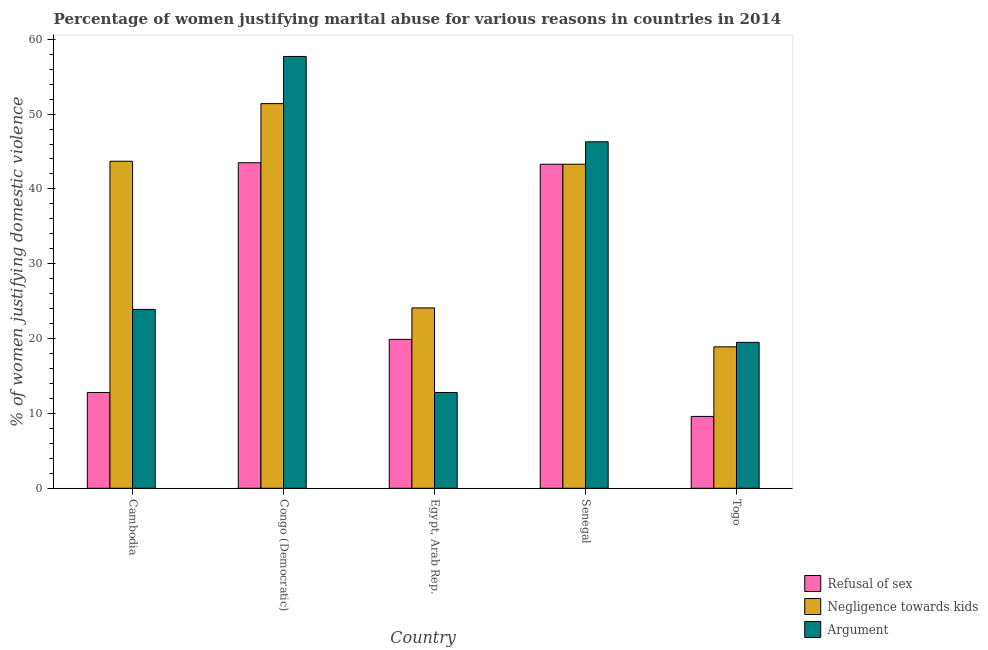How many different coloured bars are there?
Your answer should be compact. 3. Are the number of bars per tick equal to the number of legend labels?
Keep it short and to the point. Yes. Are the number of bars on each tick of the X-axis equal?
Your answer should be very brief. Yes. How many bars are there on the 4th tick from the left?
Your answer should be compact. 3. How many bars are there on the 1st tick from the right?
Your answer should be very brief. 3. What is the label of the 3rd group of bars from the left?
Provide a succinct answer. Egypt, Arab Rep. Across all countries, what is the maximum percentage of women justifying domestic violence due to arguments?
Your response must be concise. 57.7. In which country was the percentage of women justifying domestic violence due to negligence towards kids maximum?
Offer a terse response. Congo (Democratic). In which country was the percentage of women justifying domestic violence due to arguments minimum?
Make the answer very short. Egypt, Arab Rep. What is the total percentage of women justifying domestic violence due to arguments in the graph?
Offer a very short reply. 160.2. What is the difference between the percentage of women justifying domestic violence due to arguments in Cambodia and that in Egypt, Arab Rep.?
Keep it short and to the point. 11.1. What is the difference between the percentage of women justifying domestic violence due to arguments in Togo and the percentage of women justifying domestic violence due to refusal of sex in Egypt, Arab Rep.?
Provide a succinct answer. -0.4. What is the average percentage of women justifying domestic violence due to negligence towards kids per country?
Your response must be concise. 36.28. What is the difference between the percentage of women justifying domestic violence due to refusal of sex and percentage of women justifying domestic violence due to negligence towards kids in Congo (Democratic)?
Your answer should be compact. -7.9. In how many countries, is the percentage of women justifying domestic violence due to refusal of sex greater than 20 %?
Offer a very short reply. 2. What is the ratio of the percentage of women justifying domestic violence due to negligence towards kids in Congo (Democratic) to that in Togo?
Provide a short and direct response. 2.72. Is the percentage of women justifying domestic violence due to arguments in Egypt, Arab Rep. less than that in Senegal?
Offer a very short reply. Yes. What is the difference between the highest and the second highest percentage of women justifying domestic violence due to negligence towards kids?
Offer a terse response. 7.7. What is the difference between the highest and the lowest percentage of women justifying domestic violence due to negligence towards kids?
Offer a terse response. 32.5. Is the sum of the percentage of women justifying domestic violence due to negligence towards kids in Cambodia and Congo (Democratic) greater than the maximum percentage of women justifying domestic violence due to refusal of sex across all countries?
Give a very brief answer. Yes. What does the 3rd bar from the left in Senegal represents?
Make the answer very short. Argument. What does the 2nd bar from the right in Senegal represents?
Your answer should be compact. Negligence towards kids. Is it the case that in every country, the sum of the percentage of women justifying domestic violence due to refusal of sex and percentage of women justifying domestic violence due to negligence towards kids is greater than the percentage of women justifying domestic violence due to arguments?
Ensure brevity in your answer.  Yes. What is the difference between two consecutive major ticks on the Y-axis?
Offer a terse response. 10. Are the values on the major ticks of Y-axis written in scientific E-notation?
Your response must be concise. No. Where does the legend appear in the graph?
Your answer should be very brief. Bottom right. How many legend labels are there?
Offer a terse response. 3. How are the legend labels stacked?
Keep it short and to the point. Vertical. What is the title of the graph?
Your answer should be compact. Percentage of women justifying marital abuse for various reasons in countries in 2014. Does "Taxes on income" appear as one of the legend labels in the graph?
Your answer should be compact. No. What is the label or title of the Y-axis?
Give a very brief answer. % of women justifying domestic violence. What is the % of women justifying domestic violence in Refusal of sex in Cambodia?
Your answer should be very brief. 12.8. What is the % of women justifying domestic violence of Negligence towards kids in Cambodia?
Your answer should be very brief. 43.7. What is the % of women justifying domestic violence of Argument in Cambodia?
Offer a very short reply. 23.9. What is the % of women justifying domestic violence of Refusal of sex in Congo (Democratic)?
Provide a succinct answer. 43.5. What is the % of women justifying domestic violence of Negligence towards kids in Congo (Democratic)?
Your answer should be very brief. 51.4. What is the % of women justifying domestic violence in Argument in Congo (Democratic)?
Your answer should be compact. 57.7. What is the % of women justifying domestic violence of Refusal of sex in Egypt, Arab Rep.?
Your answer should be compact. 19.9. What is the % of women justifying domestic violence of Negligence towards kids in Egypt, Arab Rep.?
Keep it short and to the point. 24.1. What is the % of women justifying domestic violence of Refusal of sex in Senegal?
Give a very brief answer. 43.3. What is the % of women justifying domestic violence in Negligence towards kids in Senegal?
Ensure brevity in your answer.  43.3. What is the % of women justifying domestic violence in Argument in Senegal?
Keep it short and to the point. 46.3. What is the % of women justifying domestic violence in Refusal of sex in Togo?
Offer a terse response. 9.6. What is the % of women justifying domestic violence in Negligence towards kids in Togo?
Your response must be concise. 18.9. Across all countries, what is the maximum % of women justifying domestic violence in Refusal of sex?
Offer a terse response. 43.5. Across all countries, what is the maximum % of women justifying domestic violence of Negligence towards kids?
Give a very brief answer. 51.4. Across all countries, what is the maximum % of women justifying domestic violence of Argument?
Ensure brevity in your answer.  57.7. Across all countries, what is the minimum % of women justifying domestic violence in Refusal of sex?
Your answer should be very brief. 9.6. Across all countries, what is the minimum % of women justifying domestic violence in Negligence towards kids?
Provide a succinct answer. 18.9. Across all countries, what is the minimum % of women justifying domestic violence in Argument?
Give a very brief answer. 12.8. What is the total % of women justifying domestic violence in Refusal of sex in the graph?
Your answer should be very brief. 129.1. What is the total % of women justifying domestic violence of Negligence towards kids in the graph?
Offer a very short reply. 181.4. What is the total % of women justifying domestic violence of Argument in the graph?
Keep it short and to the point. 160.2. What is the difference between the % of women justifying domestic violence in Refusal of sex in Cambodia and that in Congo (Democratic)?
Ensure brevity in your answer.  -30.7. What is the difference between the % of women justifying domestic violence in Negligence towards kids in Cambodia and that in Congo (Democratic)?
Make the answer very short. -7.7. What is the difference between the % of women justifying domestic violence of Argument in Cambodia and that in Congo (Democratic)?
Offer a very short reply. -33.8. What is the difference between the % of women justifying domestic violence of Negligence towards kids in Cambodia and that in Egypt, Arab Rep.?
Offer a very short reply. 19.6. What is the difference between the % of women justifying domestic violence in Argument in Cambodia and that in Egypt, Arab Rep.?
Your answer should be very brief. 11.1. What is the difference between the % of women justifying domestic violence in Refusal of sex in Cambodia and that in Senegal?
Provide a succinct answer. -30.5. What is the difference between the % of women justifying domestic violence in Argument in Cambodia and that in Senegal?
Offer a very short reply. -22.4. What is the difference between the % of women justifying domestic violence of Negligence towards kids in Cambodia and that in Togo?
Offer a very short reply. 24.8. What is the difference between the % of women justifying domestic violence in Argument in Cambodia and that in Togo?
Make the answer very short. 4.4. What is the difference between the % of women justifying domestic violence in Refusal of sex in Congo (Democratic) and that in Egypt, Arab Rep.?
Your answer should be very brief. 23.6. What is the difference between the % of women justifying domestic violence of Negligence towards kids in Congo (Democratic) and that in Egypt, Arab Rep.?
Provide a succinct answer. 27.3. What is the difference between the % of women justifying domestic violence of Argument in Congo (Democratic) and that in Egypt, Arab Rep.?
Provide a short and direct response. 44.9. What is the difference between the % of women justifying domestic violence of Negligence towards kids in Congo (Democratic) and that in Senegal?
Give a very brief answer. 8.1. What is the difference between the % of women justifying domestic violence of Refusal of sex in Congo (Democratic) and that in Togo?
Your response must be concise. 33.9. What is the difference between the % of women justifying domestic violence in Negligence towards kids in Congo (Democratic) and that in Togo?
Make the answer very short. 32.5. What is the difference between the % of women justifying domestic violence in Argument in Congo (Democratic) and that in Togo?
Keep it short and to the point. 38.2. What is the difference between the % of women justifying domestic violence in Refusal of sex in Egypt, Arab Rep. and that in Senegal?
Your answer should be very brief. -23.4. What is the difference between the % of women justifying domestic violence of Negligence towards kids in Egypt, Arab Rep. and that in Senegal?
Make the answer very short. -19.2. What is the difference between the % of women justifying domestic violence of Argument in Egypt, Arab Rep. and that in Senegal?
Offer a terse response. -33.5. What is the difference between the % of women justifying domestic violence in Argument in Egypt, Arab Rep. and that in Togo?
Your answer should be compact. -6.7. What is the difference between the % of women justifying domestic violence of Refusal of sex in Senegal and that in Togo?
Ensure brevity in your answer.  33.7. What is the difference between the % of women justifying domestic violence in Negligence towards kids in Senegal and that in Togo?
Your answer should be compact. 24.4. What is the difference between the % of women justifying domestic violence in Argument in Senegal and that in Togo?
Offer a very short reply. 26.8. What is the difference between the % of women justifying domestic violence of Refusal of sex in Cambodia and the % of women justifying domestic violence of Negligence towards kids in Congo (Democratic)?
Keep it short and to the point. -38.6. What is the difference between the % of women justifying domestic violence in Refusal of sex in Cambodia and the % of women justifying domestic violence in Argument in Congo (Democratic)?
Ensure brevity in your answer.  -44.9. What is the difference between the % of women justifying domestic violence of Refusal of sex in Cambodia and the % of women justifying domestic violence of Negligence towards kids in Egypt, Arab Rep.?
Your answer should be very brief. -11.3. What is the difference between the % of women justifying domestic violence in Negligence towards kids in Cambodia and the % of women justifying domestic violence in Argument in Egypt, Arab Rep.?
Make the answer very short. 30.9. What is the difference between the % of women justifying domestic violence of Refusal of sex in Cambodia and the % of women justifying domestic violence of Negligence towards kids in Senegal?
Offer a terse response. -30.5. What is the difference between the % of women justifying domestic violence in Refusal of sex in Cambodia and the % of women justifying domestic violence in Argument in Senegal?
Give a very brief answer. -33.5. What is the difference between the % of women justifying domestic violence in Negligence towards kids in Cambodia and the % of women justifying domestic violence in Argument in Togo?
Give a very brief answer. 24.2. What is the difference between the % of women justifying domestic violence in Refusal of sex in Congo (Democratic) and the % of women justifying domestic violence in Argument in Egypt, Arab Rep.?
Provide a succinct answer. 30.7. What is the difference between the % of women justifying domestic violence in Negligence towards kids in Congo (Democratic) and the % of women justifying domestic violence in Argument in Egypt, Arab Rep.?
Make the answer very short. 38.6. What is the difference between the % of women justifying domestic violence of Refusal of sex in Congo (Democratic) and the % of women justifying domestic violence of Negligence towards kids in Senegal?
Offer a very short reply. 0.2. What is the difference between the % of women justifying domestic violence in Refusal of sex in Congo (Democratic) and the % of women justifying domestic violence in Argument in Senegal?
Your response must be concise. -2.8. What is the difference between the % of women justifying domestic violence of Refusal of sex in Congo (Democratic) and the % of women justifying domestic violence of Negligence towards kids in Togo?
Keep it short and to the point. 24.6. What is the difference between the % of women justifying domestic violence of Refusal of sex in Congo (Democratic) and the % of women justifying domestic violence of Argument in Togo?
Give a very brief answer. 24. What is the difference between the % of women justifying domestic violence in Negligence towards kids in Congo (Democratic) and the % of women justifying domestic violence in Argument in Togo?
Offer a terse response. 31.9. What is the difference between the % of women justifying domestic violence of Refusal of sex in Egypt, Arab Rep. and the % of women justifying domestic violence of Negligence towards kids in Senegal?
Keep it short and to the point. -23.4. What is the difference between the % of women justifying domestic violence of Refusal of sex in Egypt, Arab Rep. and the % of women justifying domestic violence of Argument in Senegal?
Make the answer very short. -26.4. What is the difference between the % of women justifying domestic violence in Negligence towards kids in Egypt, Arab Rep. and the % of women justifying domestic violence in Argument in Senegal?
Offer a very short reply. -22.2. What is the difference between the % of women justifying domestic violence in Refusal of sex in Egypt, Arab Rep. and the % of women justifying domestic violence in Negligence towards kids in Togo?
Your response must be concise. 1. What is the difference between the % of women justifying domestic violence of Negligence towards kids in Egypt, Arab Rep. and the % of women justifying domestic violence of Argument in Togo?
Ensure brevity in your answer.  4.6. What is the difference between the % of women justifying domestic violence in Refusal of sex in Senegal and the % of women justifying domestic violence in Negligence towards kids in Togo?
Offer a terse response. 24.4. What is the difference between the % of women justifying domestic violence in Refusal of sex in Senegal and the % of women justifying domestic violence in Argument in Togo?
Make the answer very short. 23.8. What is the difference between the % of women justifying domestic violence in Negligence towards kids in Senegal and the % of women justifying domestic violence in Argument in Togo?
Offer a very short reply. 23.8. What is the average % of women justifying domestic violence in Refusal of sex per country?
Make the answer very short. 25.82. What is the average % of women justifying domestic violence of Negligence towards kids per country?
Offer a very short reply. 36.28. What is the average % of women justifying domestic violence in Argument per country?
Keep it short and to the point. 32.04. What is the difference between the % of women justifying domestic violence of Refusal of sex and % of women justifying domestic violence of Negligence towards kids in Cambodia?
Your response must be concise. -30.9. What is the difference between the % of women justifying domestic violence in Negligence towards kids and % of women justifying domestic violence in Argument in Cambodia?
Your answer should be very brief. 19.8. What is the difference between the % of women justifying domestic violence in Refusal of sex and % of women justifying domestic violence in Negligence towards kids in Congo (Democratic)?
Provide a succinct answer. -7.9. What is the difference between the % of women justifying domestic violence of Refusal of sex and % of women justifying domestic violence of Argument in Congo (Democratic)?
Give a very brief answer. -14.2. What is the difference between the % of women justifying domestic violence in Refusal of sex and % of women justifying domestic violence in Negligence towards kids in Egypt, Arab Rep.?
Your answer should be compact. -4.2. What is the difference between the % of women justifying domestic violence of Negligence towards kids and % of women justifying domestic violence of Argument in Egypt, Arab Rep.?
Make the answer very short. 11.3. What is the difference between the % of women justifying domestic violence in Refusal of sex and % of women justifying domestic violence in Negligence towards kids in Senegal?
Your answer should be compact. 0. What is the ratio of the % of women justifying domestic violence in Refusal of sex in Cambodia to that in Congo (Democratic)?
Your response must be concise. 0.29. What is the ratio of the % of women justifying domestic violence in Negligence towards kids in Cambodia to that in Congo (Democratic)?
Offer a terse response. 0.85. What is the ratio of the % of women justifying domestic violence of Argument in Cambodia to that in Congo (Democratic)?
Provide a short and direct response. 0.41. What is the ratio of the % of women justifying domestic violence in Refusal of sex in Cambodia to that in Egypt, Arab Rep.?
Your response must be concise. 0.64. What is the ratio of the % of women justifying domestic violence of Negligence towards kids in Cambodia to that in Egypt, Arab Rep.?
Make the answer very short. 1.81. What is the ratio of the % of women justifying domestic violence in Argument in Cambodia to that in Egypt, Arab Rep.?
Provide a short and direct response. 1.87. What is the ratio of the % of women justifying domestic violence in Refusal of sex in Cambodia to that in Senegal?
Your answer should be very brief. 0.3. What is the ratio of the % of women justifying domestic violence of Negligence towards kids in Cambodia to that in Senegal?
Make the answer very short. 1.01. What is the ratio of the % of women justifying domestic violence of Argument in Cambodia to that in Senegal?
Your answer should be compact. 0.52. What is the ratio of the % of women justifying domestic violence of Refusal of sex in Cambodia to that in Togo?
Your answer should be compact. 1.33. What is the ratio of the % of women justifying domestic violence in Negligence towards kids in Cambodia to that in Togo?
Give a very brief answer. 2.31. What is the ratio of the % of women justifying domestic violence of Argument in Cambodia to that in Togo?
Your response must be concise. 1.23. What is the ratio of the % of women justifying domestic violence of Refusal of sex in Congo (Democratic) to that in Egypt, Arab Rep.?
Keep it short and to the point. 2.19. What is the ratio of the % of women justifying domestic violence of Negligence towards kids in Congo (Democratic) to that in Egypt, Arab Rep.?
Your answer should be compact. 2.13. What is the ratio of the % of women justifying domestic violence of Argument in Congo (Democratic) to that in Egypt, Arab Rep.?
Offer a very short reply. 4.51. What is the ratio of the % of women justifying domestic violence of Negligence towards kids in Congo (Democratic) to that in Senegal?
Your answer should be compact. 1.19. What is the ratio of the % of women justifying domestic violence in Argument in Congo (Democratic) to that in Senegal?
Keep it short and to the point. 1.25. What is the ratio of the % of women justifying domestic violence in Refusal of sex in Congo (Democratic) to that in Togo?
Your answer should be very brief. 4.53. What is the ratio of the % of women justifying domestic violence of Negligence towards kids in Congo (Democratic) to that in Togo?
Offer a terse response. 2.72. What is the ratio of the % of women justifying domestic violence in Argument in Congo (Democratic) to that in Togo?
Provide a short and direct response. 2.96. What is the ratio of the % of women justifying domestic violence in Refusal of sex in Egypt, Arab Rep. to that in Senegal?
Keep it short and to the point. 0.46. What is the ratio of the % of women justifying domestic violence in Negligence towards kids in Egypt, Arab Rep. to that in Senegal?
Offer a very short reply. 0.56. What is the ratio of the % of women justifying domestic violence in Argument in Egypt, Arab Rep. to that in Senegal?
Your answer should be very brief. 0.28. What is the ratio of the % of women justifying domestic violence in Refusal of sex in Egypt, Arab Rep. to that in Togo?
Provide a short and direct response. 2.07. What is the ratio of the % of women justifying domestic violence of Negligence towards kids in Egypt, Arab Rep. to that in Togo?
Ensure brevity in your answer.  1.28. What is the ratio of the % of women justifying domestic violence of Argument in Egypt, Arab Rep. to that in Togo?
Offer a terse response. 0.66. What is the ratio of the % of women justifying domestic violence of Refusal of sex in Senegal to that in Togo?
Ensure brevity in your answer.  4.51. What is the ratio of the % of women justifying domestic violence in Negligence towards kids in Senegal to that in Togo?
Your answer should be very brief. 2.29. What is the ratio of the % of women justifying domestic violence in Argument in Senegal to that in Togo?
Give a very brief answer. 2.37. What is the difference between the highest and the second highest % of women justifying domestic violence of Refusal of sex?
Offer a terse response. 0.2. What is the difference between the highest and the lowest % of women justifying domestic violence in Refusal of sex?
Give a very brief answer. 33.9. What is the difference between the highest and the lowest % of women justifying domestic violence of Negligence towards kids?
Ensure brevity in your answer.  32.5. What is the difference between the highest and the lowest % of women justifying domestic violence of Argument?
Your response must be concise. 44.9. 